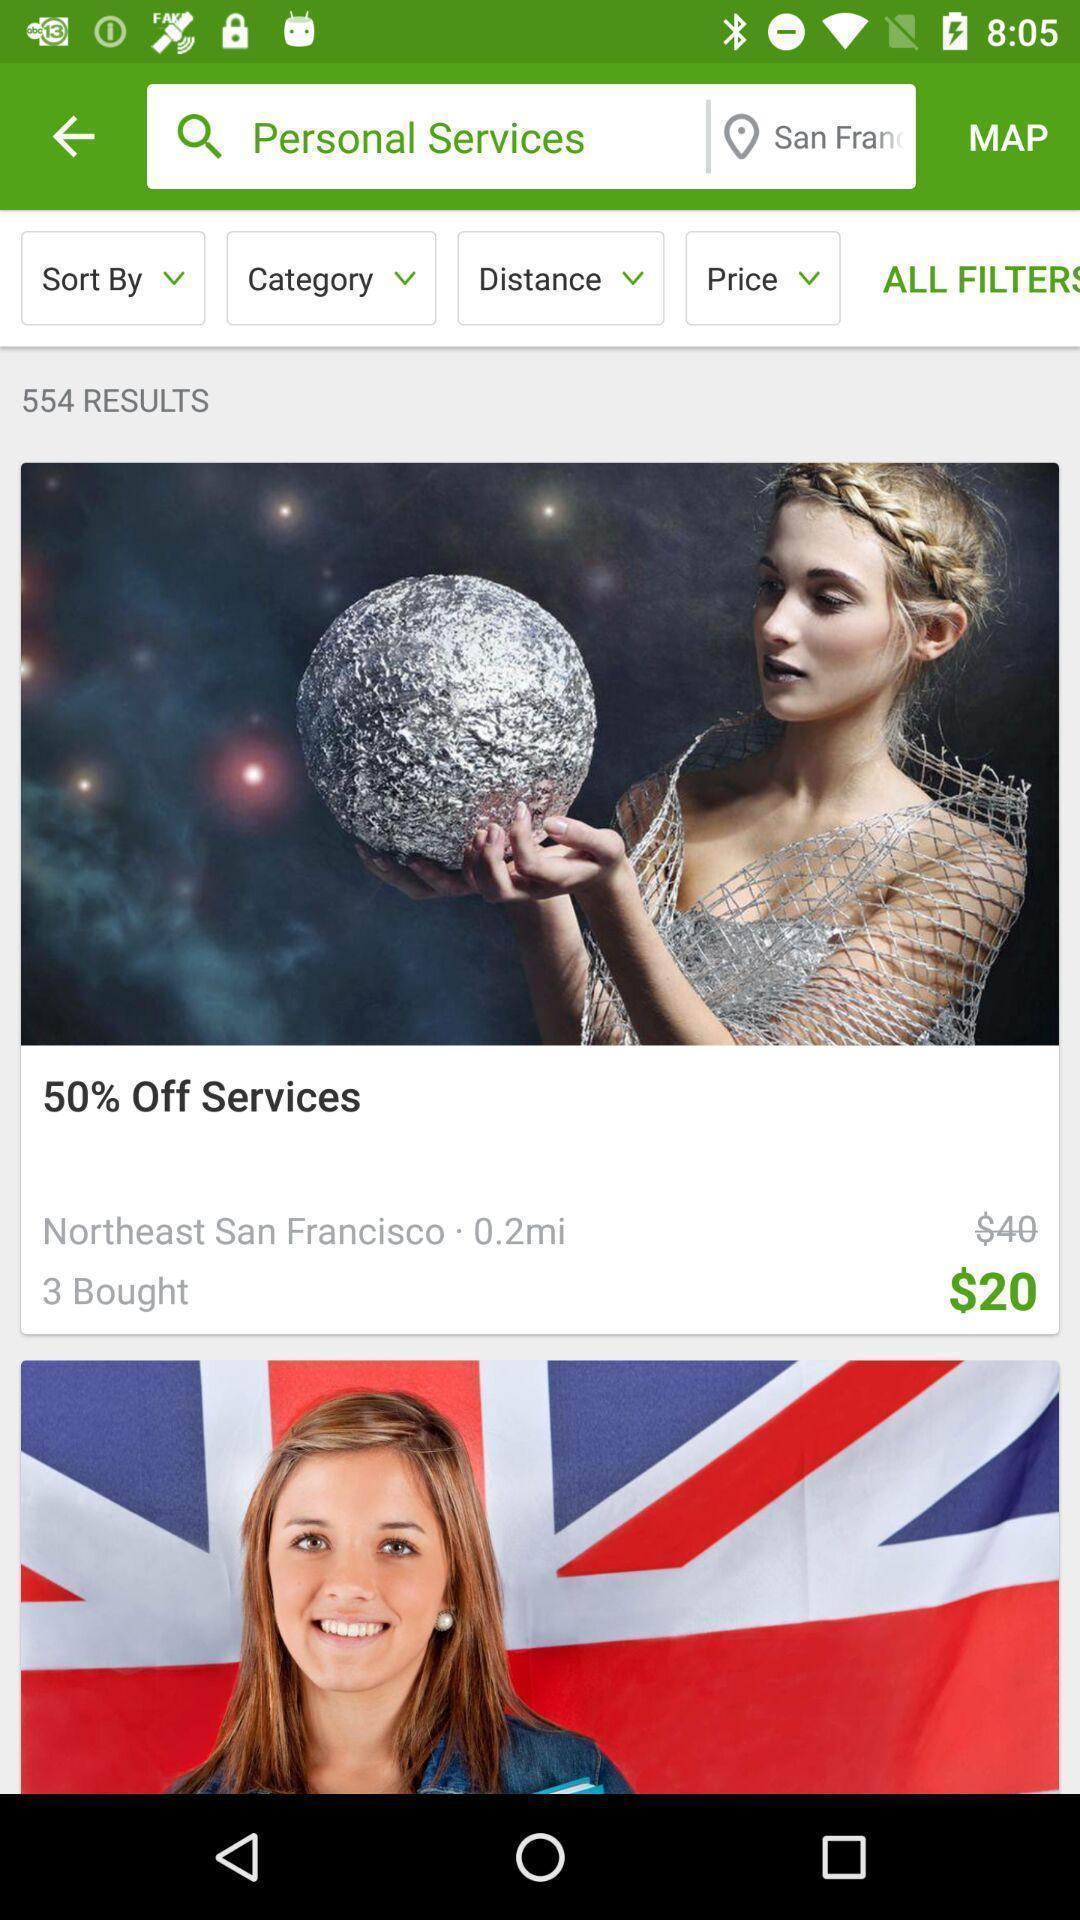Explain what's happening in this screen capture. Search page for searching a services of a shopping app. 